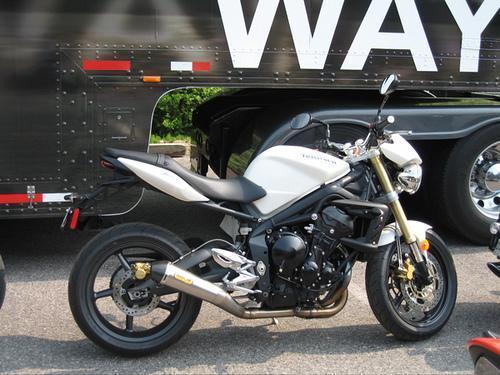How many motorcycles are in the picture?
Give a very brief answer. 1. 